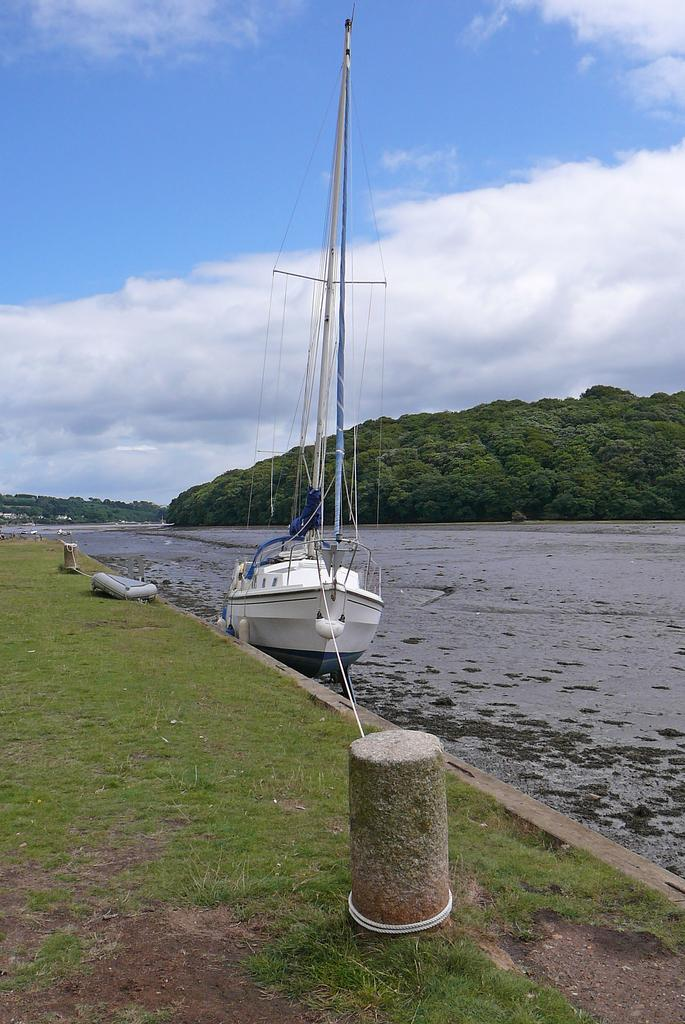What is the main subject of the image? There is a ship in the image. What is attached to the ship? There is a rope in the image. What type of environment is visible in the image? There is water, grass, and trees visible in the image. What is the condition of the sky in the image? The sky is cloudy in the image. Can you tell me how many balloons are floating above the ship in the image? There are no balloons present in the image; it only features a ship, a rope, water, grass, trees, and a cloudy sky. What type of conversation is happening between the trees in the image? There is no conversation happening between the trees in the image, as trees do not have the ability to talk. 